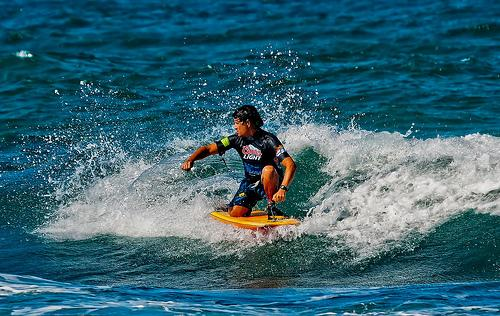How would you describe the surfer's overall look and the nature of the ocean? A tanned, dark-haired man elegantly stands on his surfboard amidst the crystal blue, lively ocean waves. What color is the surfboard, and what is special about the surfer's wetsuit? The surfboard is bright orange with a green striped pad, and the surfer's blue and black wetsuit features a prominent Coors Light sponsor logo. Mention the central action taking place in the image and the person performing it. A male surfer with black hair is skillfully riding a wave on his bright orange surfboard. State the actions being performed by the surfer and the characteristics of the water around him. A male surfer gracefully rides a foamy, white-crested wave on his vivid orange surfboard amidst the beautiful blue ocean. Mention the central figure in the image and their position on the surfboard. A man wearing a black wetsuit with dark hair is standing on his luminous orange surfboard, riding a choppy wave. Briefly describe the surfer's appearance and the environment in the image. A dark-haired man wearing a short-sleeved black wetsuit and a waterproof watch stands on his yellow surfboard amidst blue, choppy sea. Describe the color scheme of the image contents, including the ocean, surfboard, and wetsuit. The image showcases a blue choppy sea, a bright orange surfboard, and a black wetsuit with a Coors Light emblem in red and white. Detail the items present on the surfer's person and his connection to the surfboard. The surfer sports a black waterproof watch and a Coors Light logo on his wetsuit, while a blue coiled leash secures him to his orange surfboard. Using vivid adjectives, depict the scene captured in the image. An agile man in a black-and-blue wetsuit expertly navigates a tumultuous, foamy wave on his vivid orange surfboard. Narrate the surfing incident taking place in the picture. Amidst splashing waves, a determined-looking surfer with dark hair skillfully rides the wave on his yellow surfboard, defying the ocean's power. 